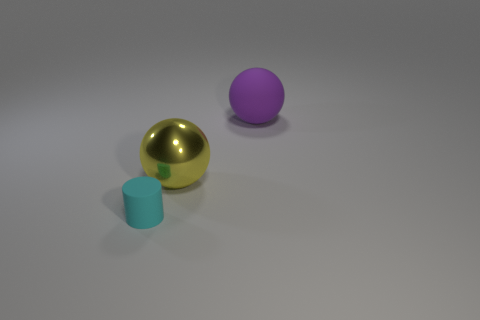There is a cyan thing that is on the left side of the large purple ball; what is it made of? Based on the image, the cyan object appears to be a simple cylindrical shape with a matte surface, similar to what you'd find in objects made of plastic in a virtual or 3D-rendered environment. This is consistent with the non-reflective and smooth texture that is often used to represent plastic materials in computer graphics. 